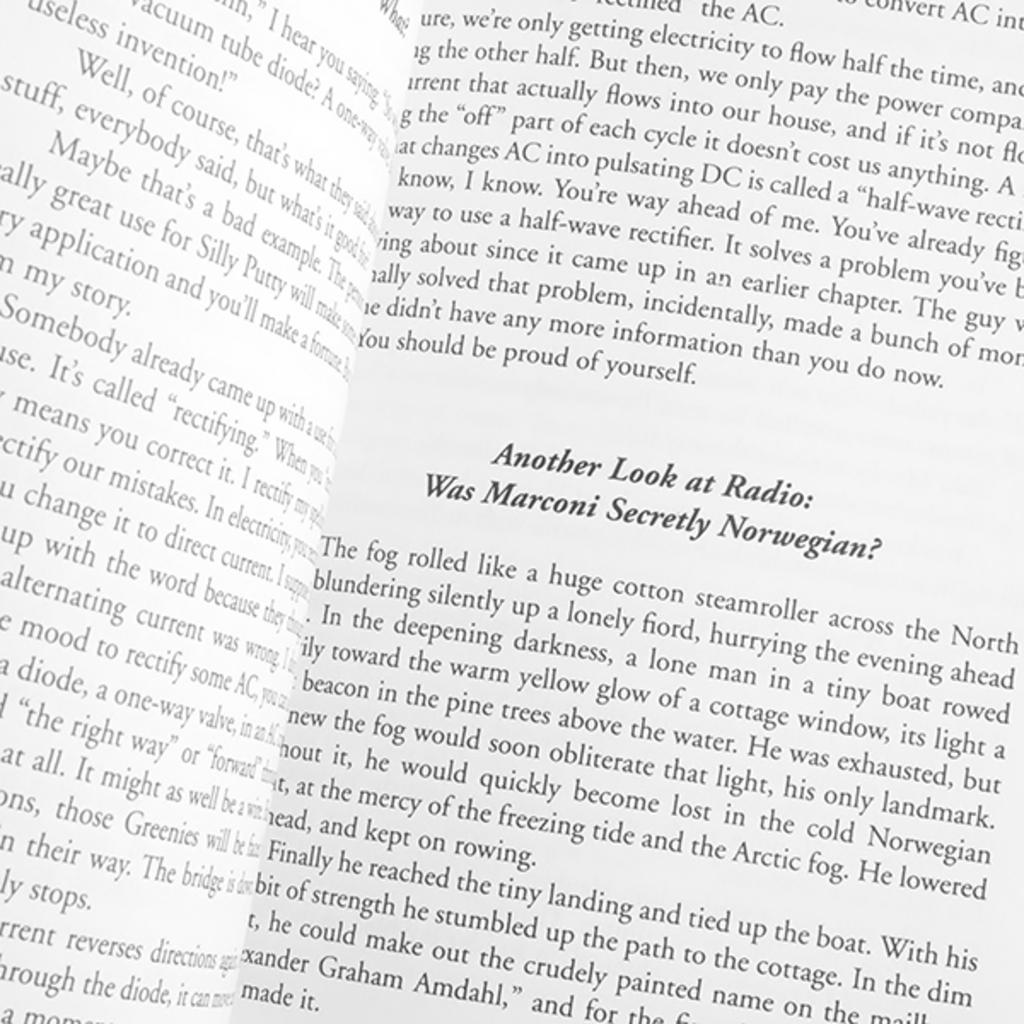<image>
Offer a succinct explanation of the picture presented. Pages of a book with a chapter referring to radio 